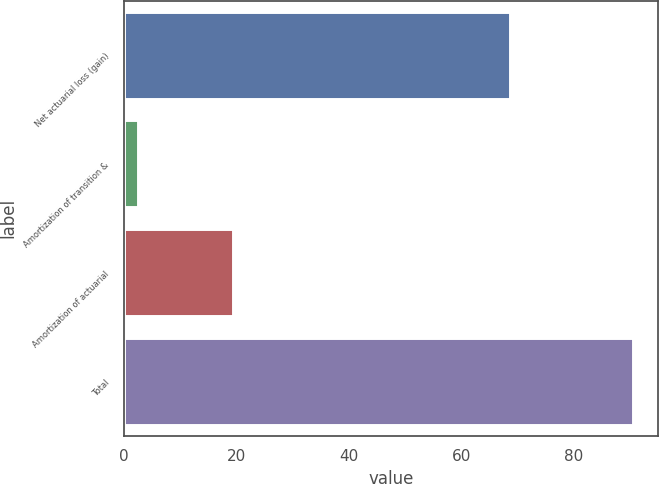Convert chart. <chart><loc_0><loc_0><loc_500><loc_500><bar_chart><fcel>Net actuarial loss (gain)<fcel>Amortization of transition &<fcel>Amortization of actuarial<fcel>Total<nl><fcel>68.7<fcel>2.5<fcel>19.3<fcel>90.5<nl></chart> 